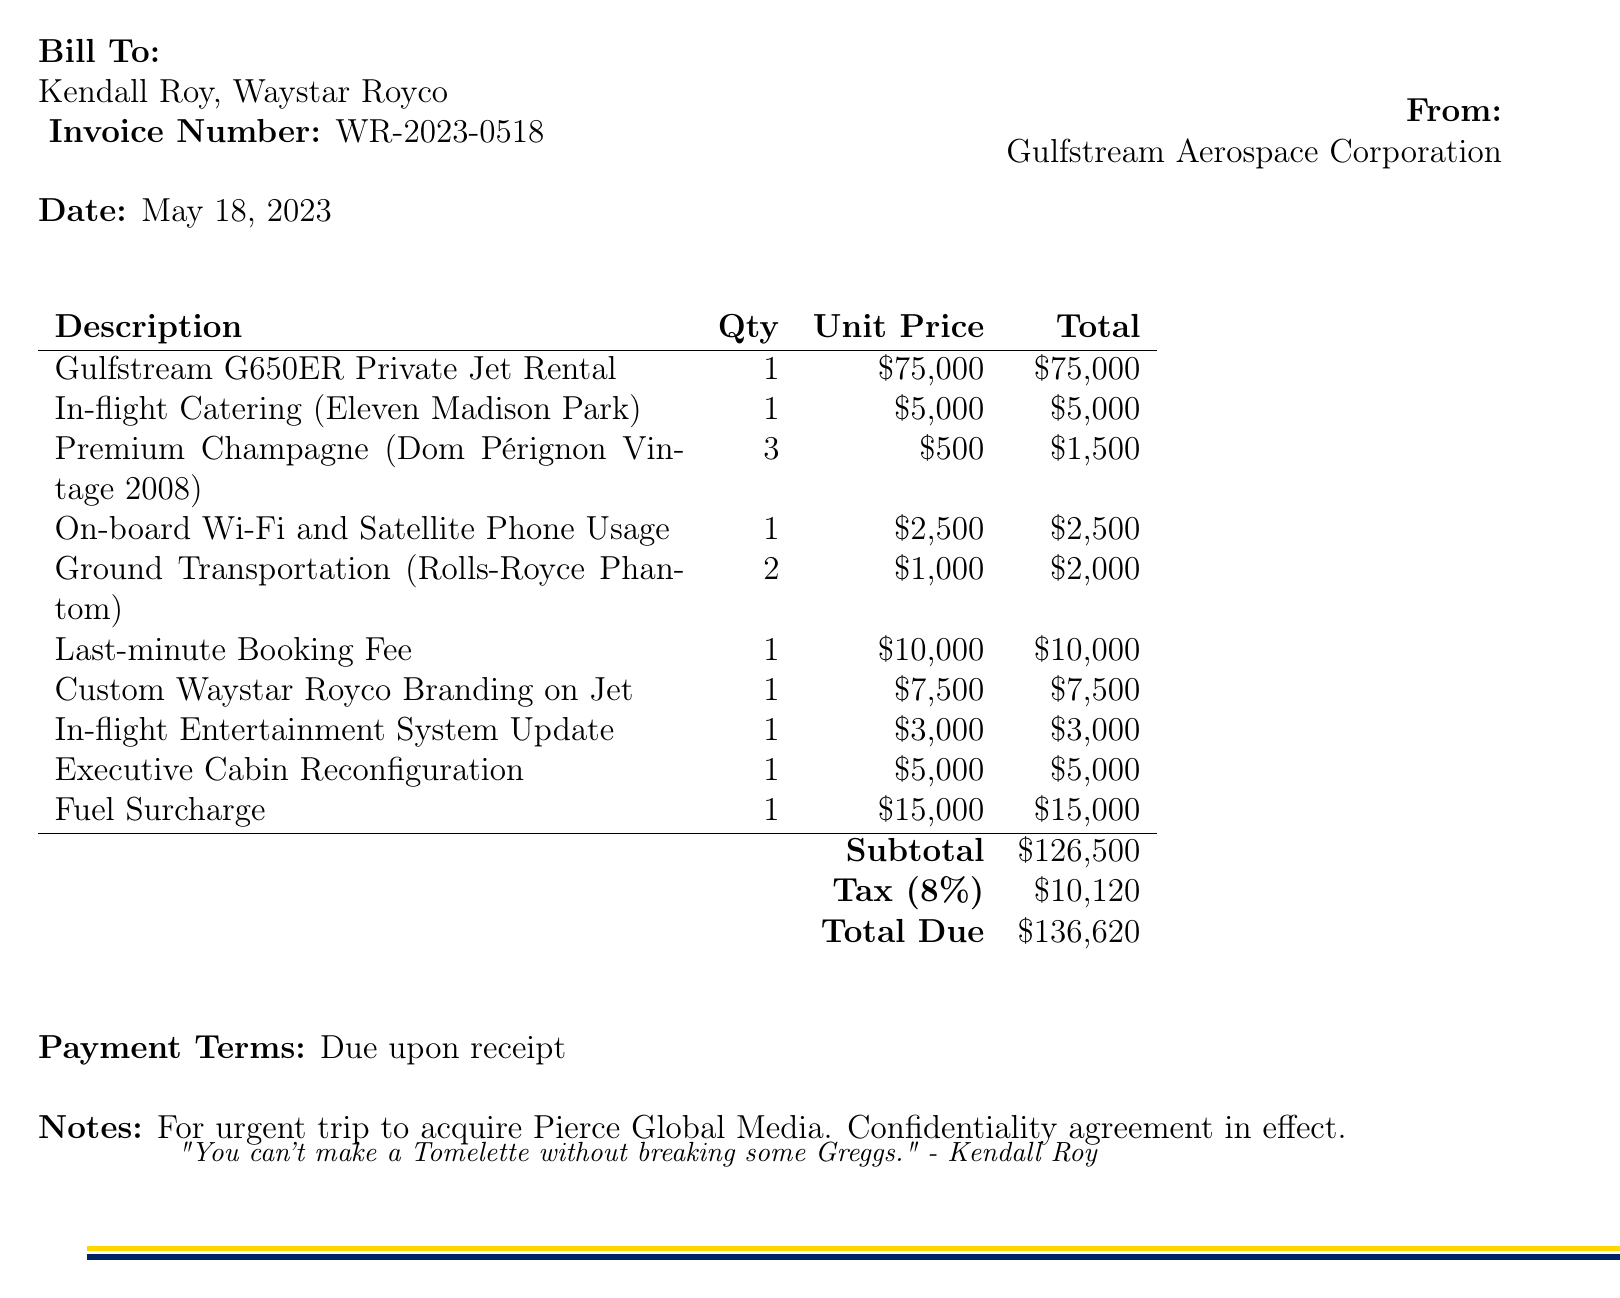What is the invoice number? The invoice number is specifically listed at the top of the document, which identifies this particular transaction.
Answer: WR-2023-0518 What is the date of the invoice? The date of the invoice can be found near the invoice number information in the document.
Answer: May 18, 2023 Who is the client listed on the invoice? The client is mentioned in the "Bill To" section, which contains the name of the individual or organization being billed.
Answer: Kendall Roy, Waystar Royco What is the total due amount? The total due is summarized at the end of the itemization on the invoice, showing the final amount to be paid.
Answer: $136,620 How much is the last-minute booking fee? The last-minute booking fee is detailed as a specific line item in the invoice, indicating the charge for urgent arrangements.
Answer: $10,000 What is the tax rate applied to this invoice? The tax rate can be found in the summarized financial details towards the end of the document, indicating the percentage applied.
Answer: 8% How many bottles of Premium Champagne are included? The quantity of Premium Champagne is specified in the list of items on the invoice, indicating how many are billed.
Answer: 3 What service is associated with the custom branding on the jet? This service involves specific customization details denoted in the list of services provided for the jet rental.
Answer: Custom Waystar Royco Branding on Jet What company provided the in-flight catering? The invoice notes which restaurant provided the in-flight catering service, giving specifics about the vendor.
Answer: Eleven Madison Park 